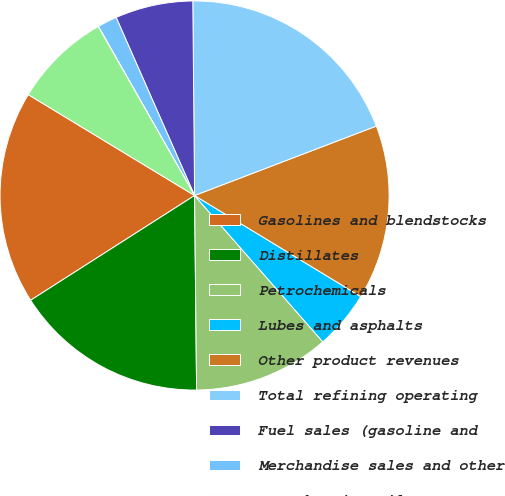Convert chart. <chart><loc_0><loc_0><loc_500><loc_500><pie_chart><fcel>Gasolines and blendstocks<fcel>Distillates<fcel>Petrochemicals<fcel>Lubes and asphalts<fcel>Other product revenues<fcel>Total refining operating<fcel>Fuel sales (gasoline and<fcel>Merchandise sales and other<fcel>Home heating oil<fcel>Total retail operating<nl><fcel>17.73%<fcel>16.12%<fcel>11.29%<fcel>4.85%<fcel>14.51%<fcel>19.34%<fcel>6.46%<fcel>1.63%<fcel>0.02%<fcel>8.07%<nl></chart> 